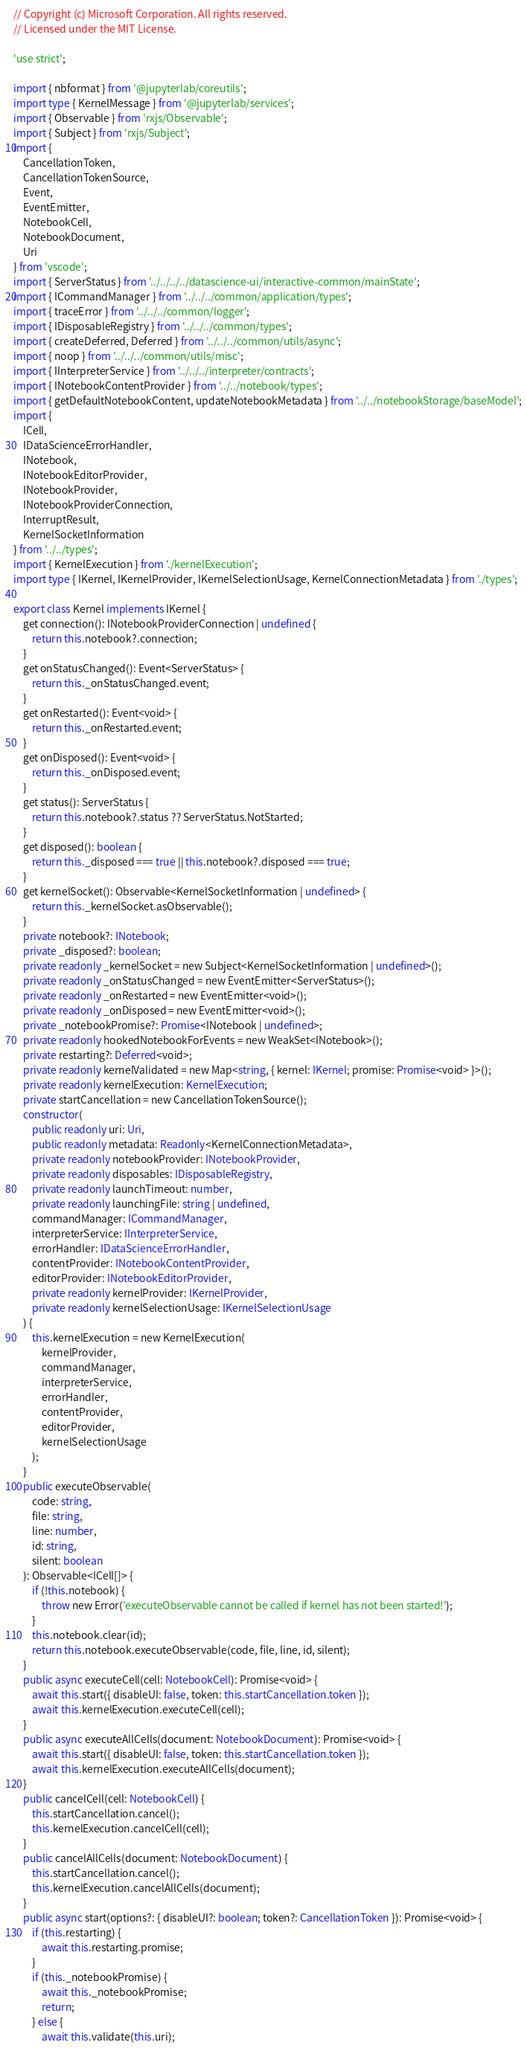<code> <loc_0><loc_0><loc_500><loc_500><_TypeScript_>// Copyright (c) Microsoft Corporation. All rights reserved.
// Licensed under the MIT License.

'use strict';

import { nbformat } from '@jupyterlab/coreutils';
import type { KernelMessage } from '@jupyterlab/services';
import { Observable } from 'rxjs/Observable';
import { Subject } from 'rxjs/Subject';
import {
    CancellationToken,
    CancellationTokenSource,
    Event,
    EventEmitter,
    NotebookCell,
    NotebookDocument,
    Uri
} from 'vscode';
import { ServerStatus } from '../../../../datascience-ui/interactive-common/mainState';
import { ICommandManager } from '../../../common/application/types';
import { traceError } from '../../../common/logger';
import { IDisposableRegistry } from '../../../common/types';
import { createDeferred, Deferred } from '../../../common/utils/async';
import { noop } from '../../../common/utils/misc';
import { IInterpreterService } from '../../../interpreter/contracts';
import { INotebookContentProvider } from '../../notebook/types';
import { getDefaultNotebookContent, updateNotebookMetadata } from '../../notebookStorage/baseModel';
import {
    ICell,
    IDataScienceErrorHandler,
    INotebook,
    INotebookEditorProvider,
    INotebookProvider,
    INotebookProviderConnection,
    InterruptResult,
    KernelSocketInformation
} from '../../types';
import { KernelExecution } from './kernelExecution';
import type { IKernel, IKernelProvider, IKernelSelectionUsage, KernelConnectionMetadata } from './types';

export class Kernel implements IKernel {
    get connection(): INotebookProviderConnection | undefined {
        return this.notebook?.connection;
    }
    get onStatusChanged(): Event<ServerStatus> {
        return this._onStatusChanged.event;
    }
    get onRestarted(): Event<void> {
        return this._onRestarted.event;
    }
    get onDisposed(): Event<void> {
        return this._onDisposed.event;
    }
    get status(): ServerStatus {
        return this.notebook?.status ?? ServerStatus.NotStarted;
    }
    get disposed(): boolean {
        return this._disposed === true || this.notebook?.disposed === true;
    }
    get kernelSocket(): Observable<KernelSocketInformation | undefined> {
        return this._kernelSocket.asObservable();
    }
    private notebook?: INotebook;
    private _disposed?: boolean;
    private readonly _kernelSocket = new Subject<KernelSocketInformation | undefined>();
    private readonly _onStatusChanged = new EventEmitter<ServerStatus>();
    private readonly _onRestarted = new EventEmitter<void>();
    private readonly _onDisposed = new EventEmitter<void>();
    private _notebookPromise?: Promise<INotebook | undefined>;
    private readonly hookedNotebookForEvents = new WeakSet<INotebook>();
    private restarting?: Deferred<void>;
    private readonly kernelValidated = new Map<string, { kernel: IKernel; promise: Promise<void> }>();
    private readonly kernelExecution: KernelExecution;
    private startCancellation = new CancellationTokenSource();
    constructor(
        public readonly uri: Uri,
        public readonly metadata: Readonly<KernelConnectionMetadata>,
        private readonly notebookProvider: INotebookProvider,
        private readonly disposables: IDisposableRegistry,
        private readonly launchTimeout: number,
        private readonly launchingFile: string | undefined,
        commandManager: ICommandManager,
        interpreterService: IInterpreterService,
        errorHandler: IDataScienceErrorHandler,
        contentProvider: INotebookContentProvider,
        editorProvider: INotebookEditorProvider,
        private readonly kernelProvider: IKernelProvider,
        private readonly kernelSelectionUsage: IKernelSelectionUsage
    ) {
        this.kernelExecution = new KernelExecution(
            kernelProvider,
            commandManager,
            interpreterService,
            errorHandler,
            contentProvider,
            editorProvider,
            kernelSelectionUsage
        );
    }
    public executeObservable(
        code: string,
        file: string,
        line: number,
        id: string,
        silent: boolean
    ): Observable<ICell[]> {
        if (!this.notebook) {
            throw new Error('executeObservable cannot be called if kernel has not been started!');
        }
        this.notebook.clear(id);
        return this.notebook.executeObservable(code, file, line, id, silent);
    }
    public async executeCell(cell: NotebookCell): Promise<void> {
        await this.start({ disableUI: false, token: this.startCancellation.token });
        await this.kernelExecution.executeCell(cell);
    }
    public async executeAllCells(document: NotebookDocument): Promise<void> {
        await this.start({ disableUI: false, token: this.startCancellation.token });
        await this.kernelExecution.executeAllCells(document);
    }
    public cancelCell(cell: NotebookCell) {
        this.startCancellation.cancel();
        this.kernelExecution.cancelCell(cell);
    }
    public cancelAllCells(document: NotebookDocument) {
        this.startCancellation.cancel();
        this.kernelExecution.cancelAllCells(document);
    }
    public async start(options?: { disableUI?: boolean; token?: CancellationToken }): Promise<void> {
        if (this.restarting) {
            await this.restarting.promise;
        }
        if (this._notebookPromise) {
            await this._notebookPromise;
            return;
        } else {
            await this.validate(this.uri);</code> 